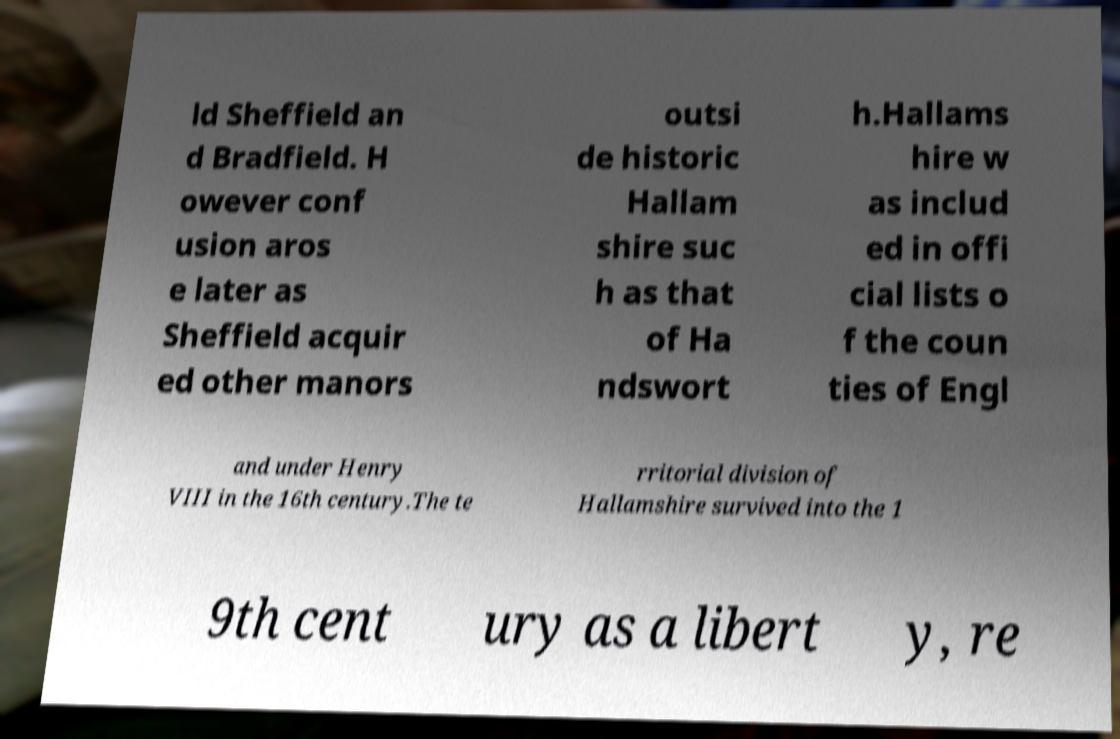Can you read and provide the text displayed in the image?This photo seems to have some interesting text. Can you extract and type it out for me? ld Sheffield an d Bradfield. H owever conf usion aros e later as Sheffield acquir ed other manors outsi de historic Hallam shire suc h as that of Ha ndswort h.Hallams hire w as includ ed in offi cial lists o f the coun ties of Engl and under Henry VIII in the 16th century.The te rritorial division of Hallamshire survived into the 1 9th cent ury as a libert y, re 